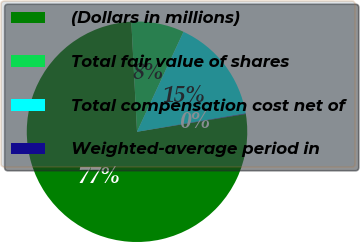Convert chart to OTSL. <chart><loc_0><loc_0><loc_500><loc_500><pie_chart><fcel>(Dollars in millions)<fcel>Total fair value of shares<fcel>Total compensation cost net of<fcel>Weighted-average period in<nl><fcel>76.76%<fcel>7.75%<fcel>15.41%<fcel>0.08%<nl></chart> 